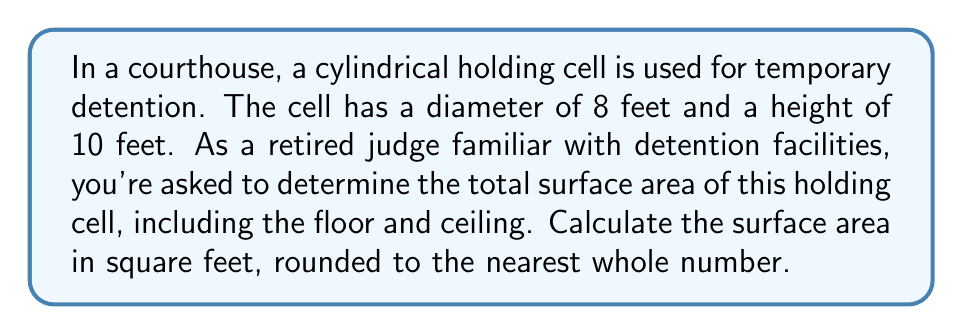Can you answer this question? To calculate the surface area of a cylindrical holding cell, we need to consider three components:
1. The lateral surface area (curved wall)
2. The area of the circular base (floor)
3. The area of the circular top (ceiling)

Let's break it down step-by-step:

1. Lateral surface area:
   - The formula for the lateral surface area of a cylinder is $A_l = 2\pi rh$
   - Radius $r = \frac{\text{diameter}}{2} = \frac{8}{2} = 4$ feet
   - Height $h = 10$ feet
   - $A_l = 2\pi (4)(10) = 80\pi$ square feet

2. Area of the circular base (floor):
   - The formula for the area of a circle is $A_c = \pi r^2$
   - $A_c = \pi (4^2) = 16\pi$ square feet

3. Area of the circular top (ceiling):
   - This is the same as the base: $16\pi$ square feet

Total surface area:
$A_{\text{total}} = A_l + 2A_c = 80\pi + 2(16\pi) = 112\pi$ square feet

Converting to a numerical value:
$A_{\text{total}} = 112\pi \approx 351.86$ square feet

Rounding to the nearest whole number: 352 square feet

[asy]
import geometry;

size(200);
real r = 4;
real h = 10;

path base = circle((0,0), r);
path top = circle((0,h), r);

draw(base);
draw(top);
draw((r,0)--(r,h));
draw((-r,0)--(-r,h));

label("8 ft", (0,-r-0.5), S);
label("10 ft", (r+0.5,h/2), E);

[/asy]
Answer: The total surface area of the cylindrical holding cell is approximately 352 square feet. 